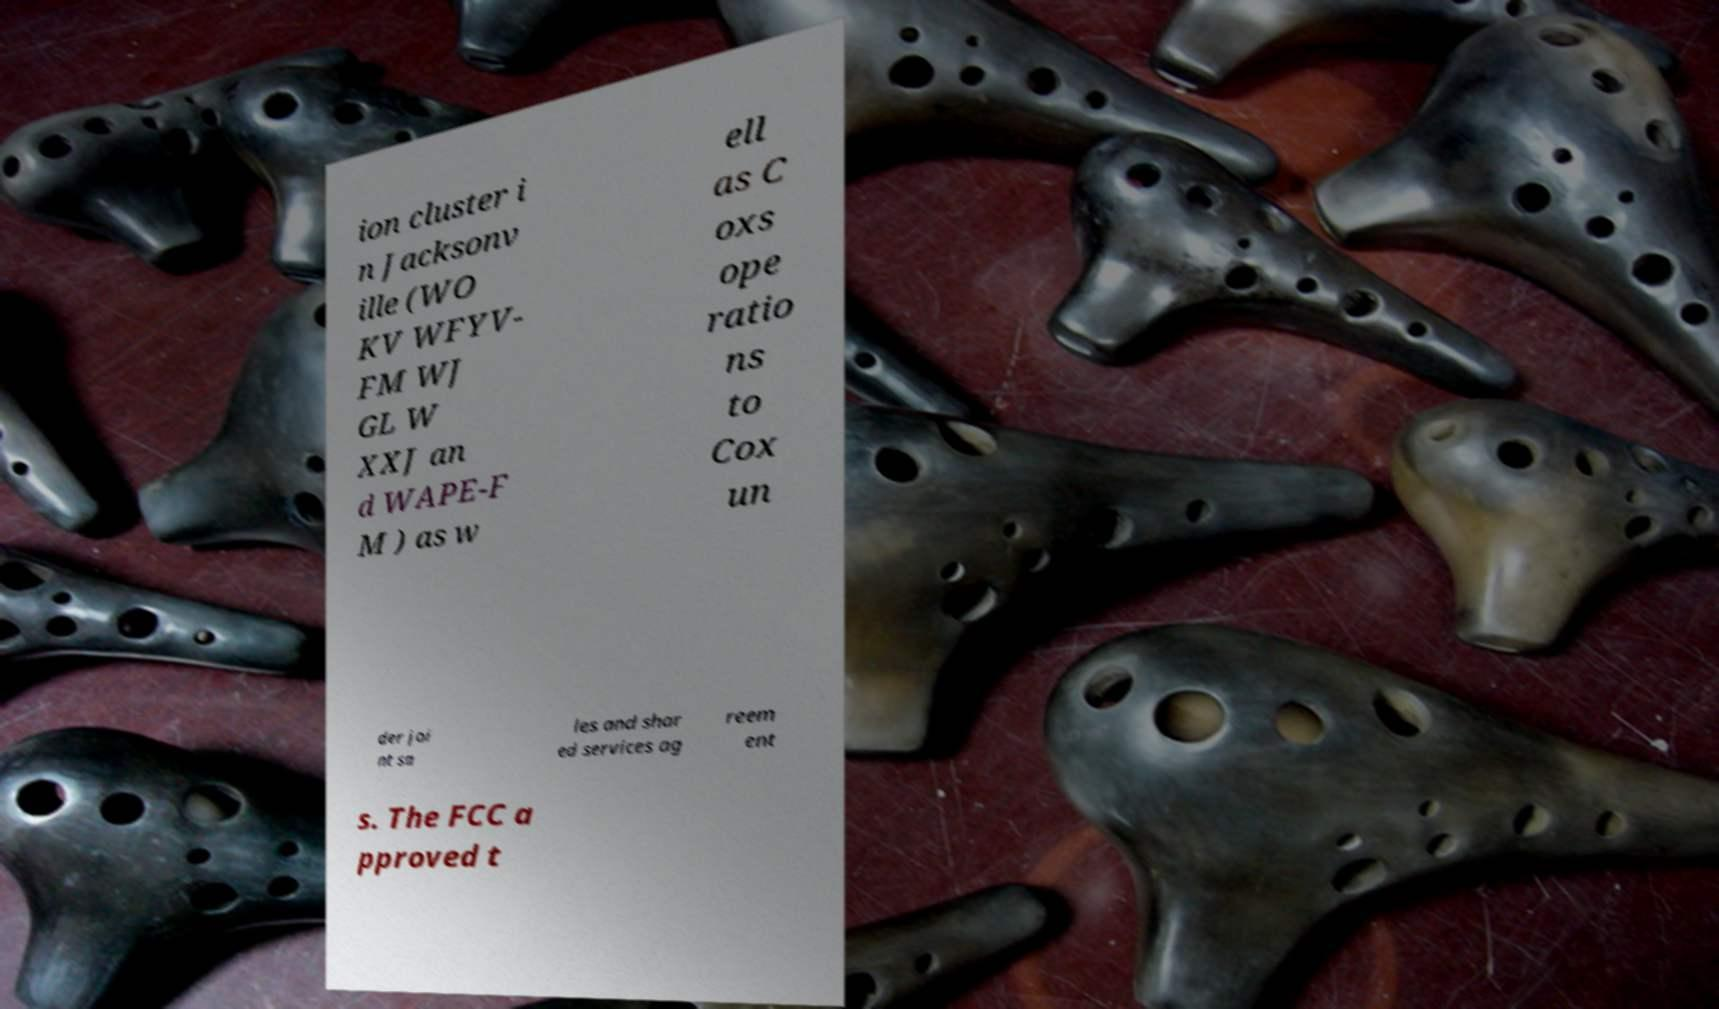For documentation purposes, I need the text within this image transcribed. Could you provide that? ion cluster i n Jacksonv ille (WO KV WFYV- FM WJ GL W XXJ an d WAPE-F M ) as w ell as C oxs ope ratio ns to Cox un der joi nt sa les and shar ed services ag reem ent s. The FCC a pproved t 